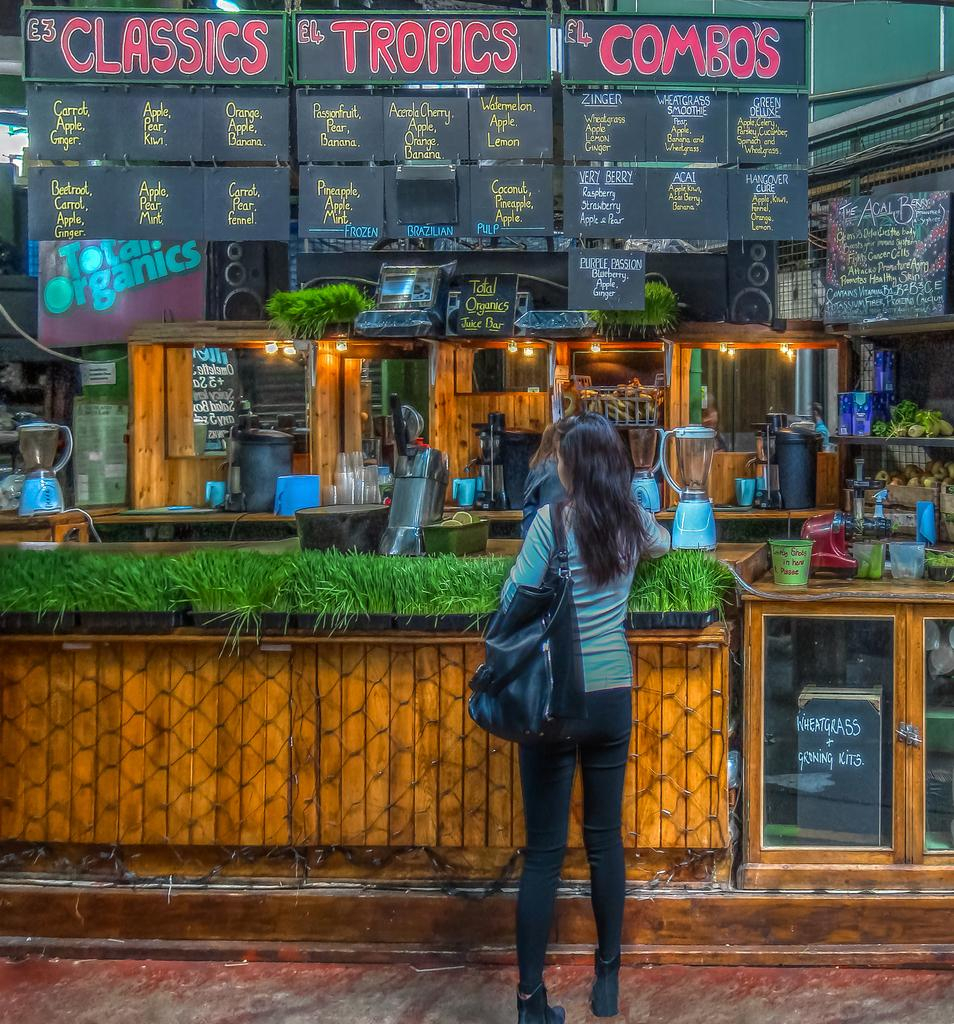What is the main subject of the image? The main subject of the image is a stall with vegetables. Can you describe the woman standing before the stall? There is a woman standing before the stall facing towards the back. Are there any other people present in the image? Yes, there is another woman in the stall. What type of gun is the woman holding in the image? There is no gun present in the image; the woman is standing before a stall with vegetables. Is there a bomb visible in the image? No, there is no bomb present in the image. 